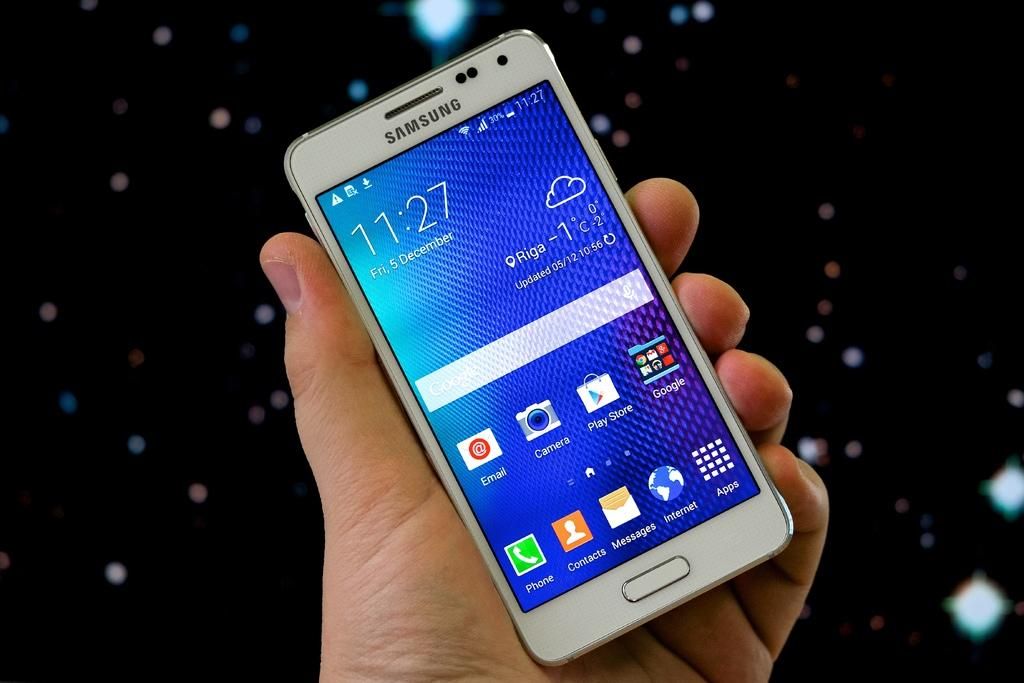<image>
Describe the image concisely. a Samsung cell phone with the time of 11:27 displayed 